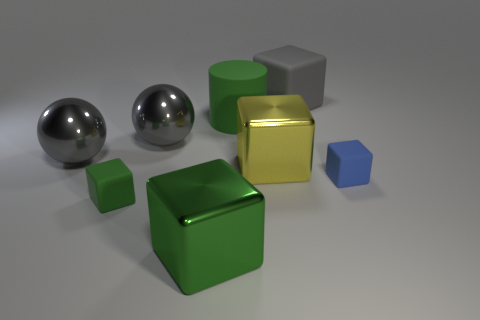Subtract all red cubes. Subtract all gray spheres. How many cubes are left? 5 Add 1 big gray rubber cubes. How many objects exist? 9 Subtract all balls. How many objects are left? 6 Add 7 blue matte things. How many blue matte things are left? 8 Add 1 big rubber objects. How many big rubber objects exist? 3 Subtract 0 purple cubes. How many objects are left? 8 Subtract all purple balls. Subtract all big green cubes. How many objects are left? 7 